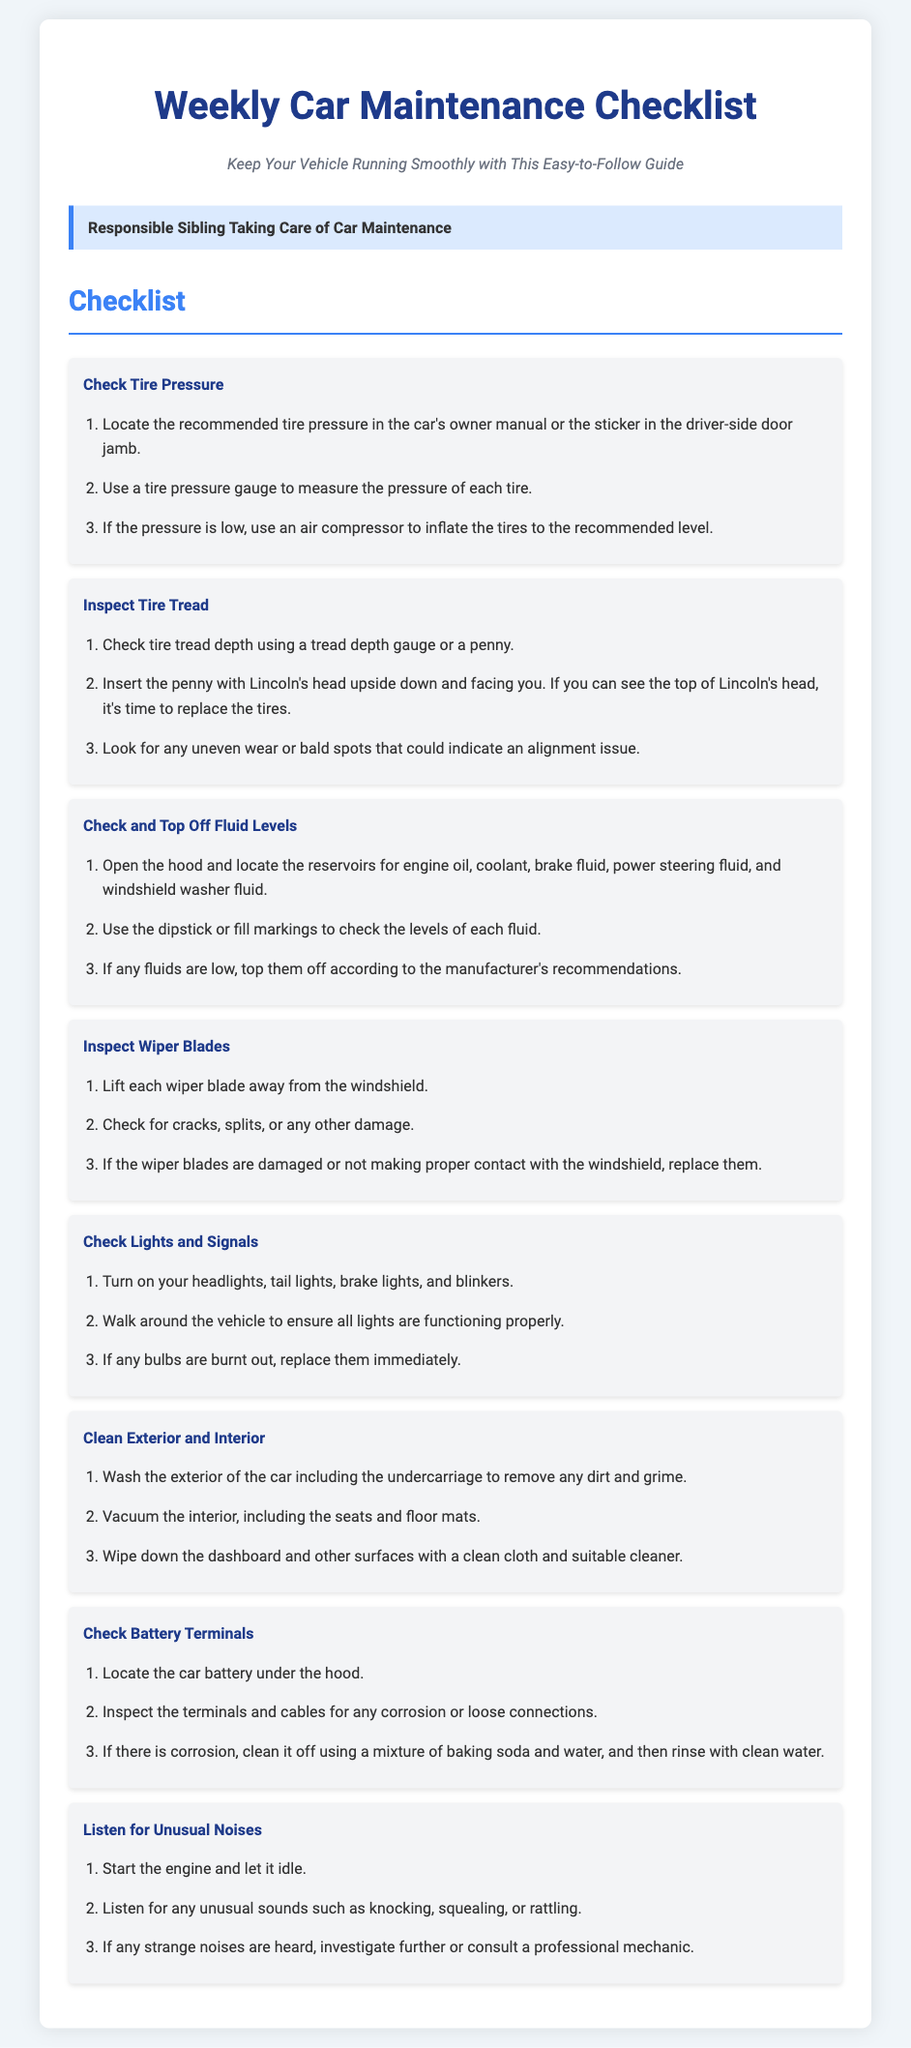what is the title of the document? The title of the document is presented prominently at the top of the page.
Answer: Weekly Car Maintenance Checklist who is the persona in the document? The persona is highlighted in a dedicated box within the document context.
Answer: Responsible Sibling Taking Care of Car Maintenance how many tasks are included in the checklist? The number of tasks can be determined by counting the checklist items provided in the document.
Answer: 8 what should you check to ensure your tires are in good condition? The checklist includes specific actions regarding tire condition, which are detailed underneath the tire inspection task.
Answer: Tire Pressure and Tire Tread what should you do if fluid levels are low? This instruction is found within the fluid checks section of the checklist outlining how to handle low fluid levels.
Answer: Top Them Off what condition indicates it might be time to replace your tires? The specific guideline for determining tire replacement is detailed in the tire tread inspection task.
Answer: See the top of Lincoln's head how should you clean the battery terminals? The cleaning method for battery terminals is specified under the battery inspection task in the document.
Answer: Baking soda and water what should you do when you hear unusual noises after starting the engine? This is suggested as a follow-up action in the document to address potential issues with the vehicle.
Answer: Investigate further or consult a professional mechanic 